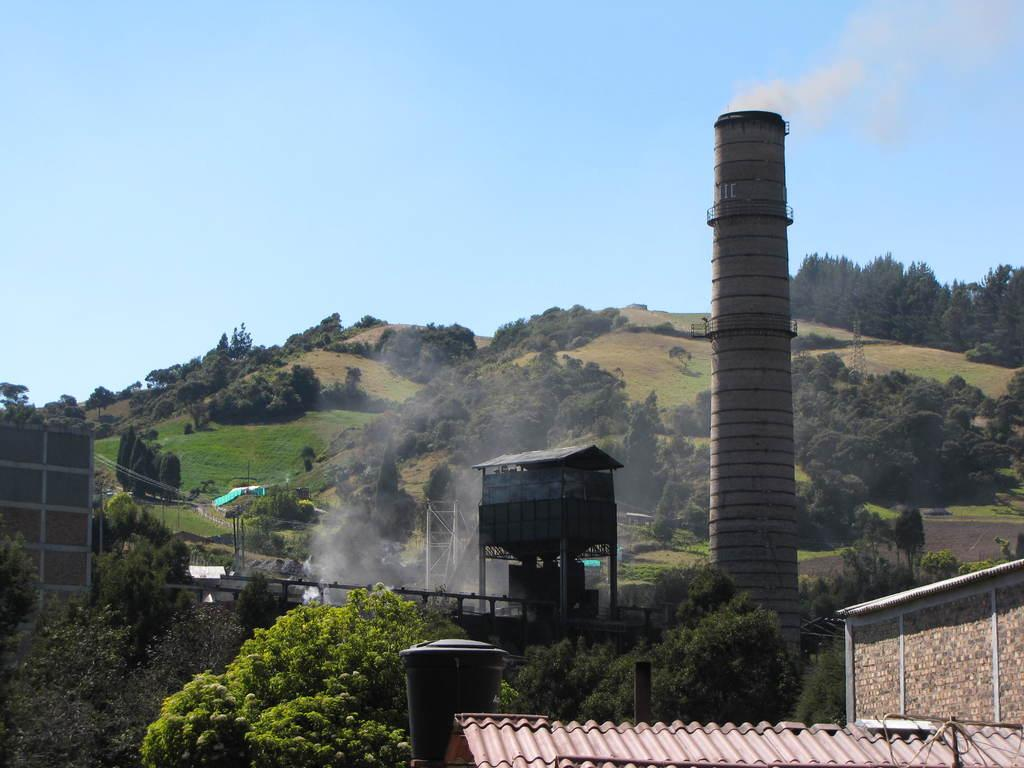What type of structures can be seen in the image? There are homes in the image. What natural elements are present in the image? There are trees and mountains in the image. What architectural feature is visible on one of the homes? There is a chimney visible in the image. What color is the sky in the image? The sky is blue at the top of the image. Can you see any lettuce growing in the image? There is no lettuce present in the image. How many wings are visible on the homes in the image? There are no wings visible on the homes in the image; they are typical residential structures. 